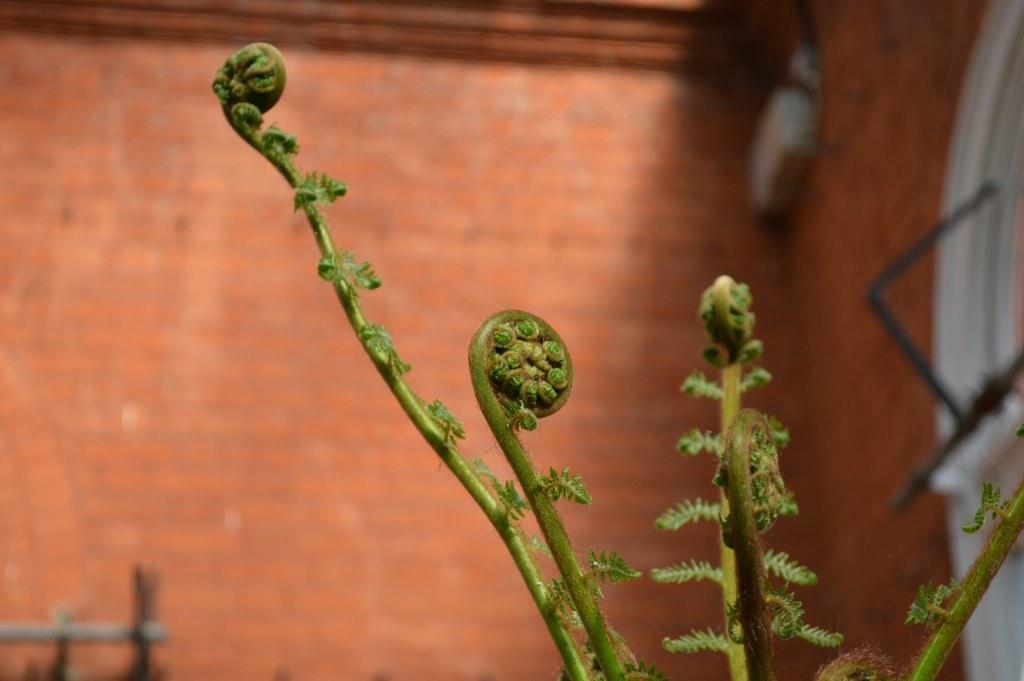What type of living organism is present in the image? There is a plant in the image. Where is the plant located in relation to the other elements in the image? The plant is at the front of the image. What type of structure is visible in the image? There is a wall in the image. Where is the wall located in relation to the plant? The wall is at the back of the image. Can you tell me how many docks are visible in the image? There are no docks present in the image. What type of house is shown in the image? There is no house shown in the image; it features a plant and a wall. 